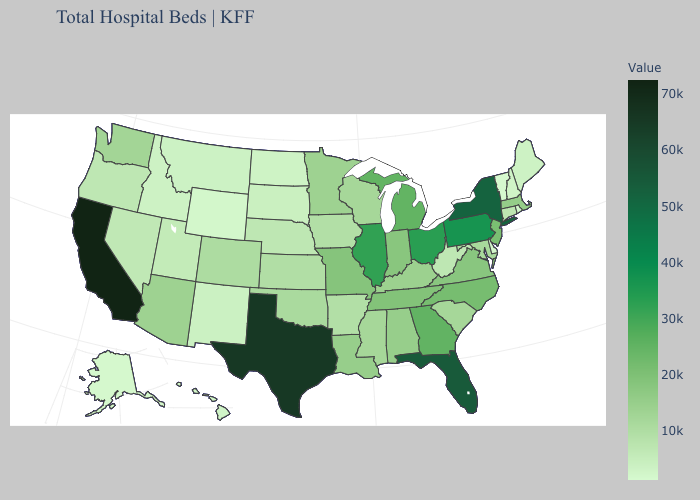Does the map have missing data?
Write a very short answer. No. Which states have the lowest value in the USA?
Keep it brief. Vermont. Among the states that border Pennsylvania , does West Virginia have the highest value?
Keep it brief. No. Does Texas have the highest value in the South?
Keep it brief. Yes. Is the legend a continuous bar?
Concise answer only. Yes. Which states hav the highest value in the South?
Short answer required. Texas. Does Georgia have the lowest value in the USA?
Short answer required. No. Does Delaware have the lowest value in the South?
Keep it brief. Yes. Among the states that border North Carolina , does Georgia have the lowest value?
Be succinct. No. 